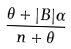<formula> <loc_0><loc_0><loc_500><loc_500>\frac { \theta + | B | \alpha } { n + \theta }</formula> 